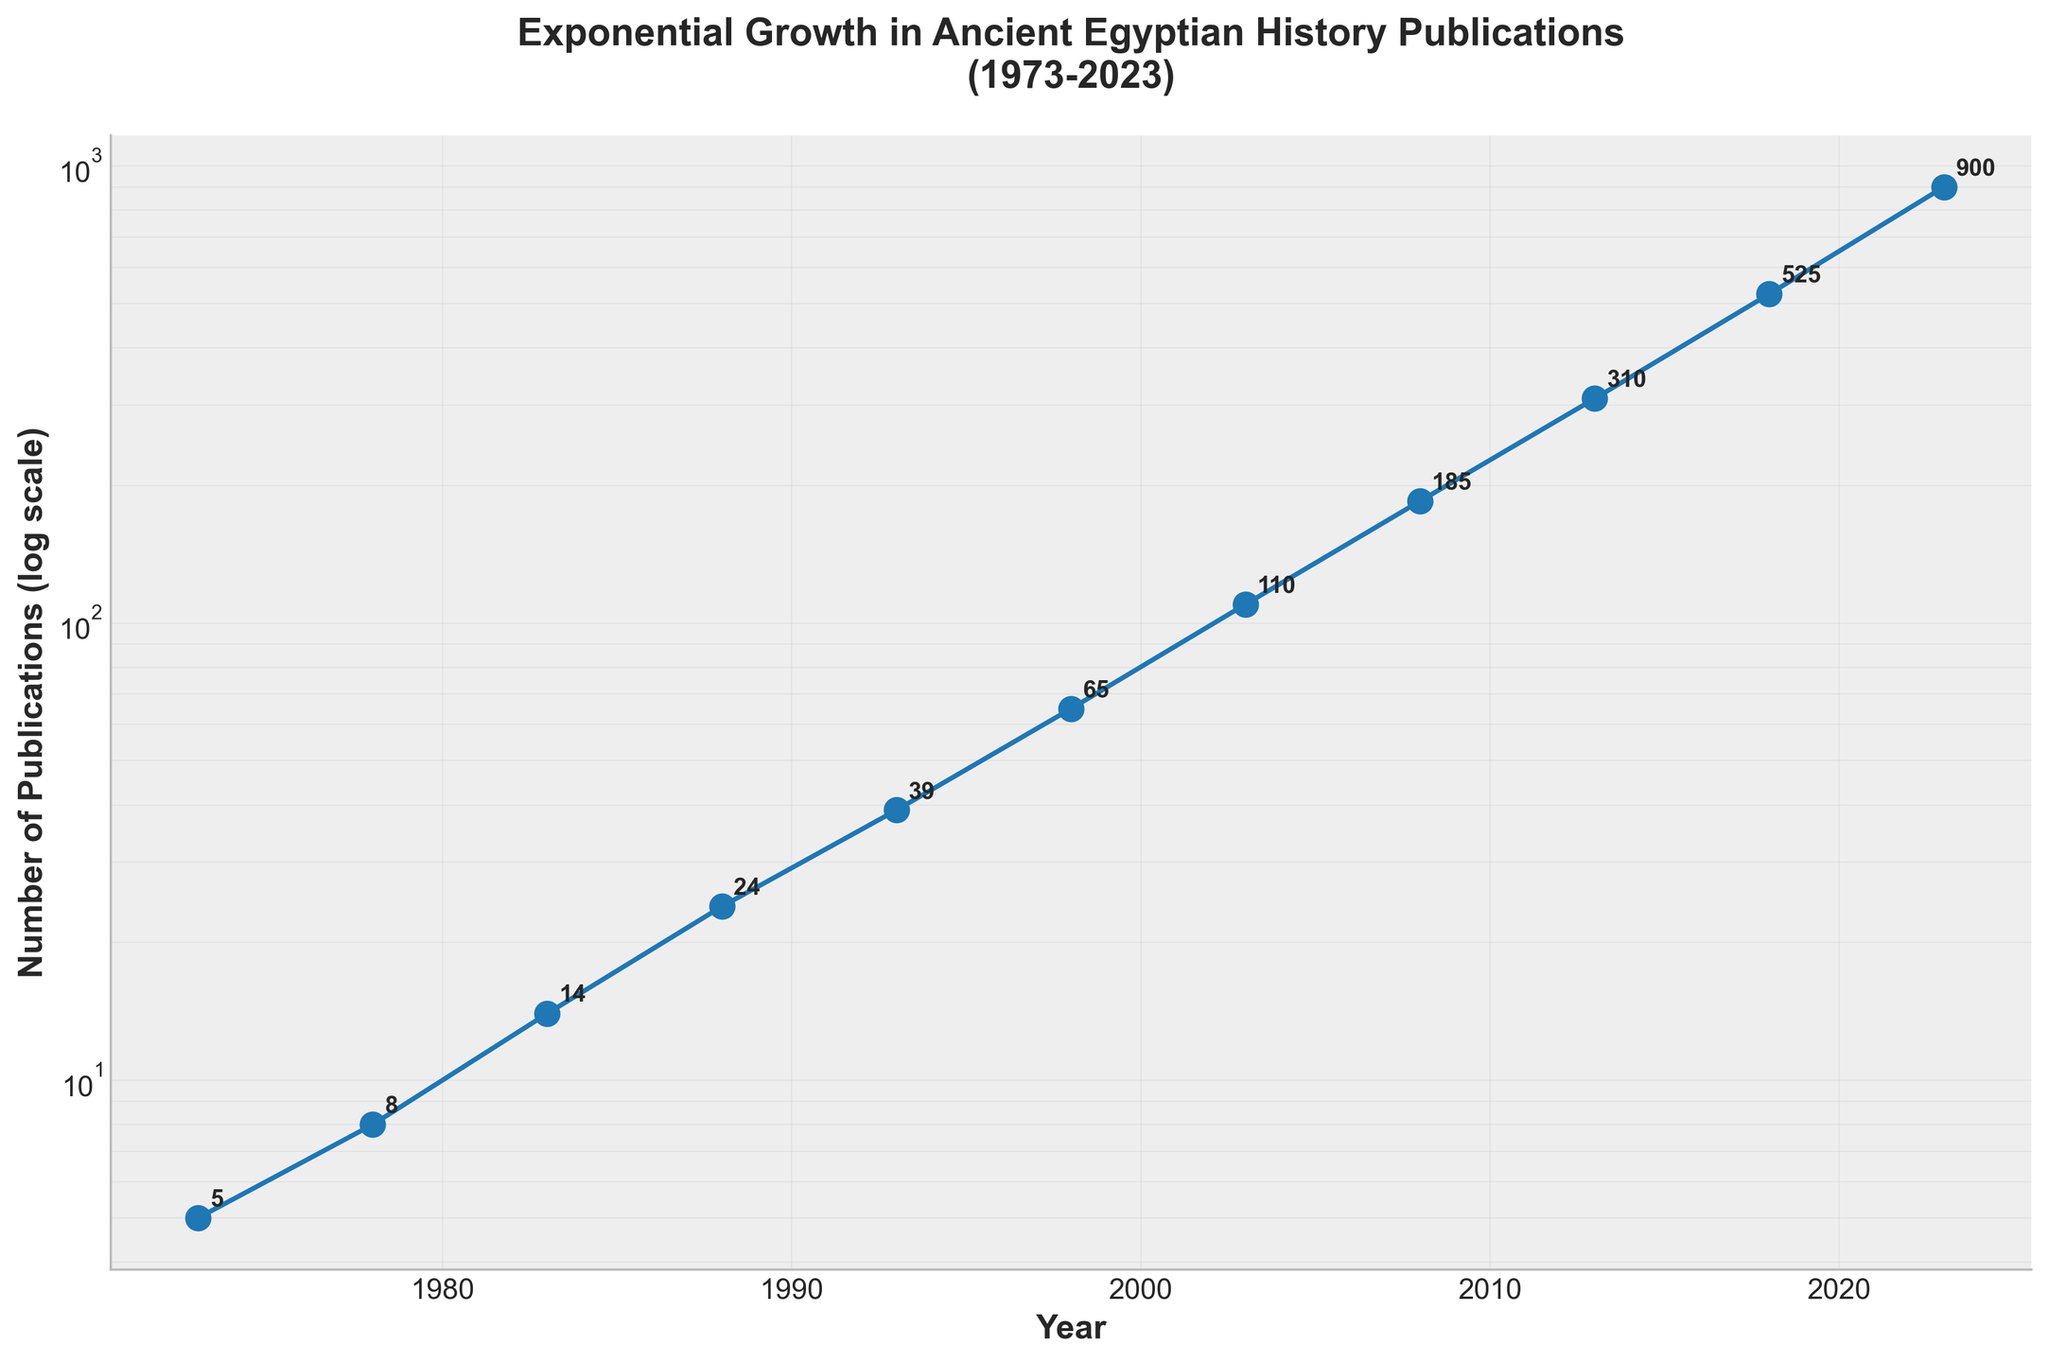What's the title of the plot? The title is usually displayed at the top of the figure and is designed to provide a succinct description of the figure's content.
Answer: Exponential Growth in Ancient Egyptian History Publications (1973-2023) What is the label of the y-axis? The y-axis label provides information about the data being visualized on the y-axis. It's typically located next to the y-axis.
Answer: Number of Publications (log scale) How many data points are shown on the plot? To determine the number of data points, count the number of markers or points plotted on the figure. Each point represents a specific data entry.
Answer: 11 What year shows the highest number of publications? By examining the plot, identify the year that corresponds to the highest point on the y-axis. This is the year when the number of publications peaked.
Answer: 2023 Between which consecutive years did the number of publications show the greatest increase? To determine this, calculate the difference in the number of publications between each pair of consecutive years and find the maximum difference.
Answer: 2018 and 2023 What was the total number of publications in the first two decades (1973-1993)? Sum the number of publications for the years 1973, 1978, 1983, and 1988. For 1993, consider a full two decades starting from 1973.
Answer: 5 + 8 + 14 + 24 = 51 By what factor did the number of publications increase from 1993 to 2023? Divide the number of publications in 2023 by the number of publications in 1993 to get the multiplication factor.
Answer: 900 / 39 ≈ 23 What can be inferred from the trend of the plot? Observing the overall trend and pattern of the data points on the log scale plot gives an insight into the nature of growth over time.
Answer: The growth is exponential Between which consecutive years did the number of publications show the smallest increase? To determine this, calculate the difference in the number of publications between each pair of consecutive years and find the minimum difference.
Answer: 1973 and 1978 